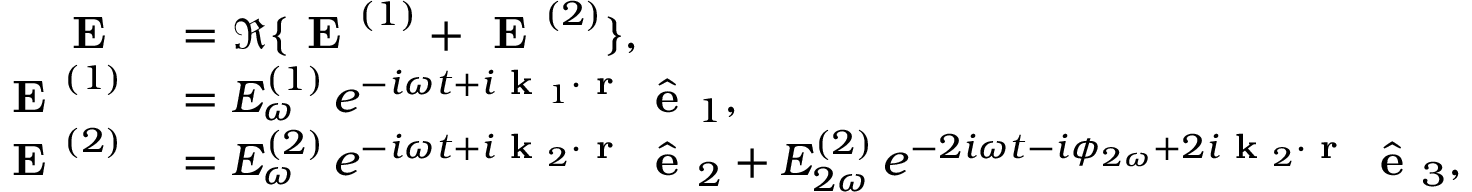Convert formula to latex. <formula><loc_0><loc_0><loc_500><loc_500>\begin{array} { r l } { E } & = \Re \{ E ^ { ( 1 ) } + E ^ { ( 2 ) } \} , } \\ { E ^ { ( 1 ) } } & = E _ { \omega } ^ { ( 1 ) } \, e ^ { - i \omega t + i k _ { 1 } \cdot r } \, \hat { e } _ { 1 } , } \\ { E ^ { ( 2 ) } } & = E _ { \omega } ^ { ( 2 ) } \, e ^ { - i \omega t + i k _ { 2 } \cdot r } \, \hat { e } _ { 2 } + E _ { 2 \omega } ^ { ( 2 ) } \, e ^ { - 2 i \omega t - i \phi _ { 2 \omega } + 2 i k _ { 2 } \cdot r } \, \hat { e } _ { 3 } , } \end{array}</formula> 